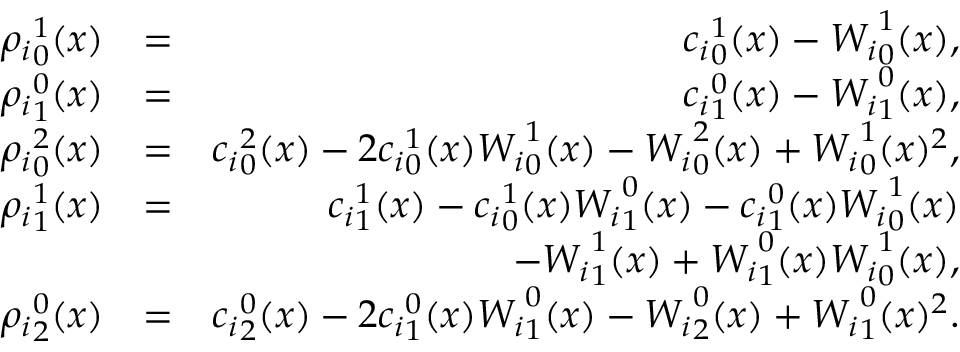<formula> <loc_0><loc_0><loc_500><loc_500>\begin{array} { r l r } { { \rho _ { i } } _ { 0 } ^ { 1 } ( x ) } & { = } & { { c _ { i } } _ { 0 } ^ { 1 } ( x ) - { W _ { i } } _ { 0 } ^ { 1 } ( x ) , } \\ { { \rho _ { i } } _ { 1 } ^ { 0 } ( x ) } & { = } & { { c _ { i } } _ { 1 } ^ { 0 } ( x ) - { W _ { i } } _ { 1 } ^ { 0 } ( x ) , } \\ { { \rho _ { i } } _ { 0 } ^ { 2 } ( x ) } & { = } & { { c _ { i } } _ { 0 } ^ { 2 } ( x ) - 2 { c _ { i } } _ { 0 } ^ { 1 } ( x ) { W _ { i } } _ { 0 } ^ { 1 } ( x ) - { W _ { i } } _ { 0 } ^ { 2 } ( x ) + { W _ { i } } _ { 0 } ^ { 1 } ( x ) ^ { 2 } , } \\ { { \rho _ { i } } _ { 1 } ^ { 1 } ( x ) } & { = } & { { c _ { i } } _ { 1 } ^ { 1 } ( x ) - { c _ { i } } _ { 0 } ^ { 1 } ( x ) { W _ { i } } _ { 1 } ^ { 0 } ( x ) - { c _ { i } } _ { 1 } ^ { 0 } ( x ) { W _ { i } } _ { 0 } ^ { 1 } ( x ) } \\ & { - { W _ { i } } _ { 1 } ^ { 1 } ( x ) + { W _ { i } } _ { 1 } ^ { 0 } ( x ) { W _ { i } } _ { 0 } ^ { 1 } ( x ) , } \\ { { \rho _ { i } } _ { 2 } ^ { 0 } ( x ) } & { = } & { { c _ { i } } _ { 2 } ^ { 0 } ( x ) - 2 { c _ { i } } _ { 1 } ^ { 0 } ( x ) { W _ { i } } _ { 1 } ^ { 0 } ( x ) - { W _ { i } } _ { 2 } ^ { 0 } ( x ) + { W _ { i } } _ { 1 } ^ { 0 } ( x ) ^ { 2 } . } \end{array}</formula> 